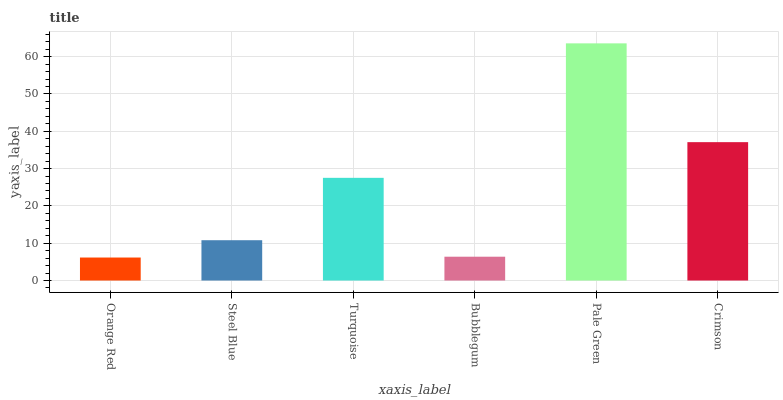Is Orange Red the minimum?
Answer yes or no. Yes. Is Pale Green the maximum?
Answer yes or no. Yes. Is Steel Blue the minimum?
Answer yes or no. No. Is Steel Blue the maximum?
Answer yes or no. No. Is Steel Blue greater than Orange Red?
Answer yes or no. Yes. Is Orange Red less than Steel Blue?
Answer yes or no. Yes. Is Orange Red greater than Steel Blue?
Answer yes or no. No. Is Steel Blue less than Orange Red?
Answer yes or no. No. Is Turquoise the high median?
Answer yes or no. Yes. Is Steel Blue the low median?
Answer yes or no. Yes. Is Pale Green the high median?
Answer yes or no. No. Is Pale Green the low median?
Answer yes or no. No. 